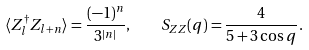Convert formula to latex. <formula><loc_0><loc_0><loc_500><loc_500>\langle Z _ { l } ^ { \dagger } Z _ { l + n } \rangle = \frac { ( - 1 ) ^ { n } } { 3 ^ { | n | } } , \quad S _ { Z Z } ( q ) = \frac { 4 } { 5 + 3 \cos q } .</formula> 